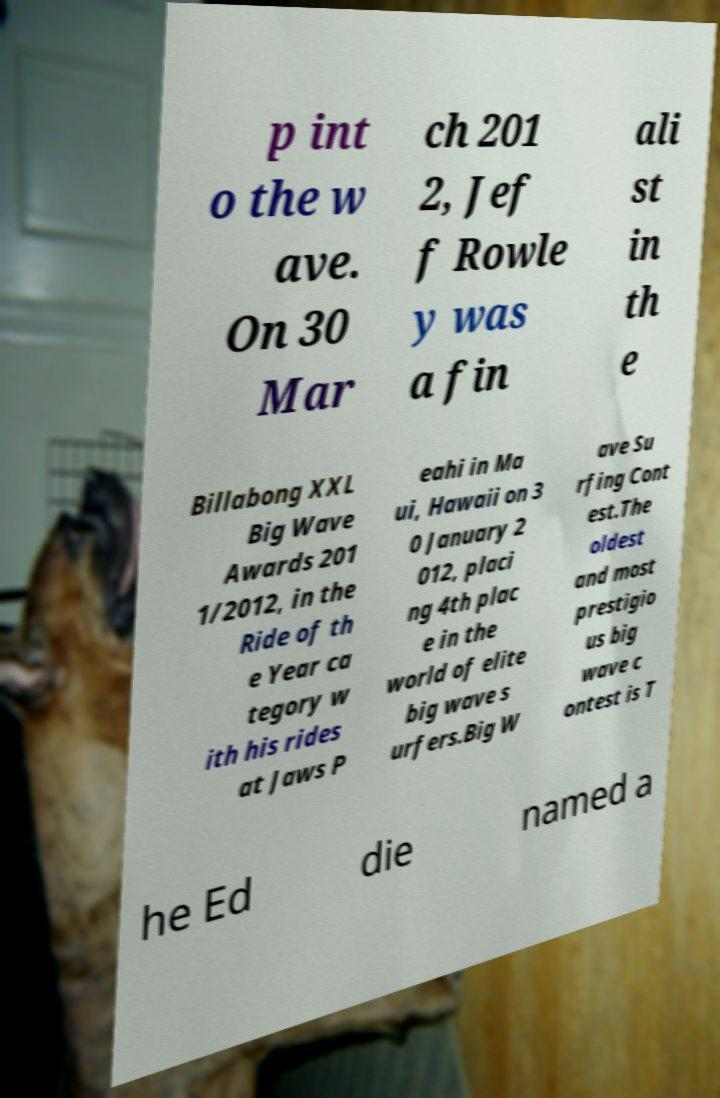Could you extract and type out the text from this image? p int o the w ave. On 30 Mar ch 201 2, Jef f Rowle y was a fin ali st in th e Billabong XXL Big Wave Awards 201 1/2012, in the Ride of th e Year ca tegory w ith his rides at Jaws P eahi in Ma ui, Hawaii on 3 0 January 2 012, placi ng 4th plac e in the world of elite big wave s urfers.Big W ave Su rfing Cont est.The oldest and most prestigio us big wave c ontest is T he Ed die named a 